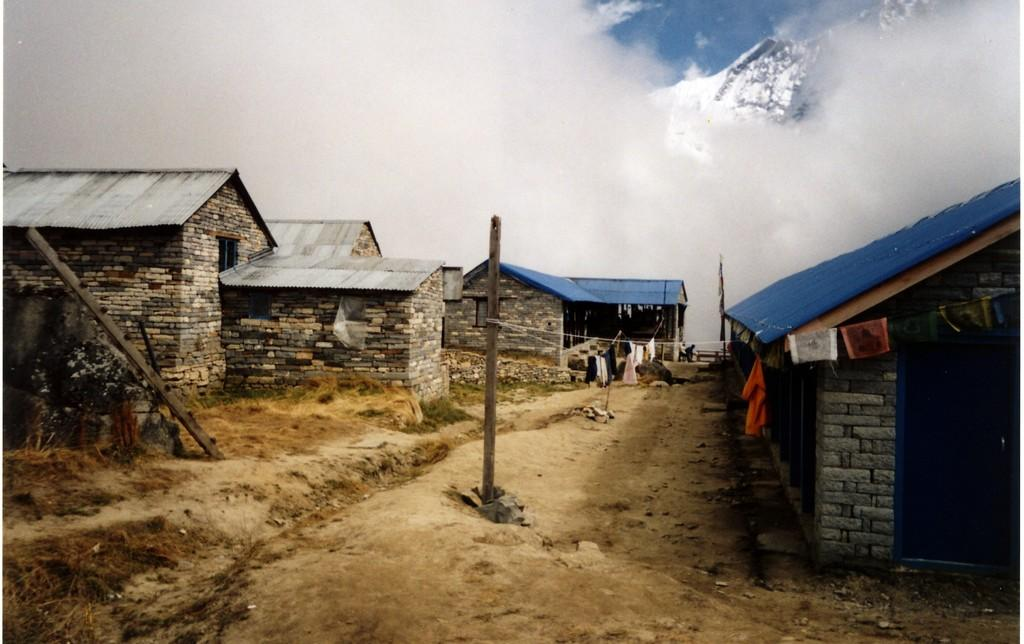What objects are present in the image that are used for hanging or suspending items? There are poles and ropes in the image that are used for hanging or suspending items. What is hanging on the ropes in the image? Clothes are hanging on the ropes in the image. What type of structures can be seen in the image? There are houses in the image. What is the ground covered with in the image? Dry grass is present on the ground in the image. What is visible in the sky in the image? The sky is visible in the image. What type of jail can be seen in the image? There is no jail present in the image; it features poles, ropes, clothes, houses, dry grass, and the sky. Can you tell me how many sea creatures are visible in the image? There are no sea creatures present in the image; it does not depict any marine environment. 